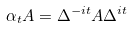<formula> <loc_0><loc_0><loc_500><loc_500>\alpha _ { t } A = \Delta ^ { - i t } A \Delta ^ { i t }</formula> 